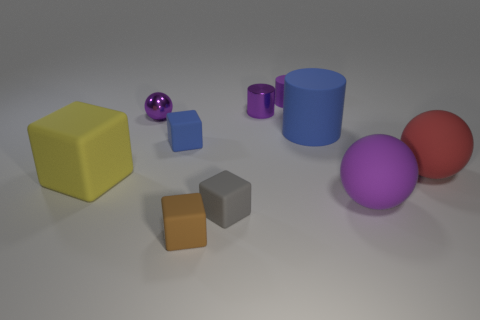Subtract 1 cylinders. How many cylinders are left? 2 Subtract all brown blocks. How many blocks are left? 3 Subtract all green blocks. Subtract all red cylinders. How many blocks are left? 4 Subtract all cubes. How many objects are left? 6 Add 9 small blue objects. How many small blue objects are left? 10 Add 5 matte cubes. How many matte cubes exist? 9 Subtract 0 red cylinders. How many objects are left? 10 Subtract all tiny blue rubber blocks. Subtract all purple matte cylinders. How many objects are left? 8 